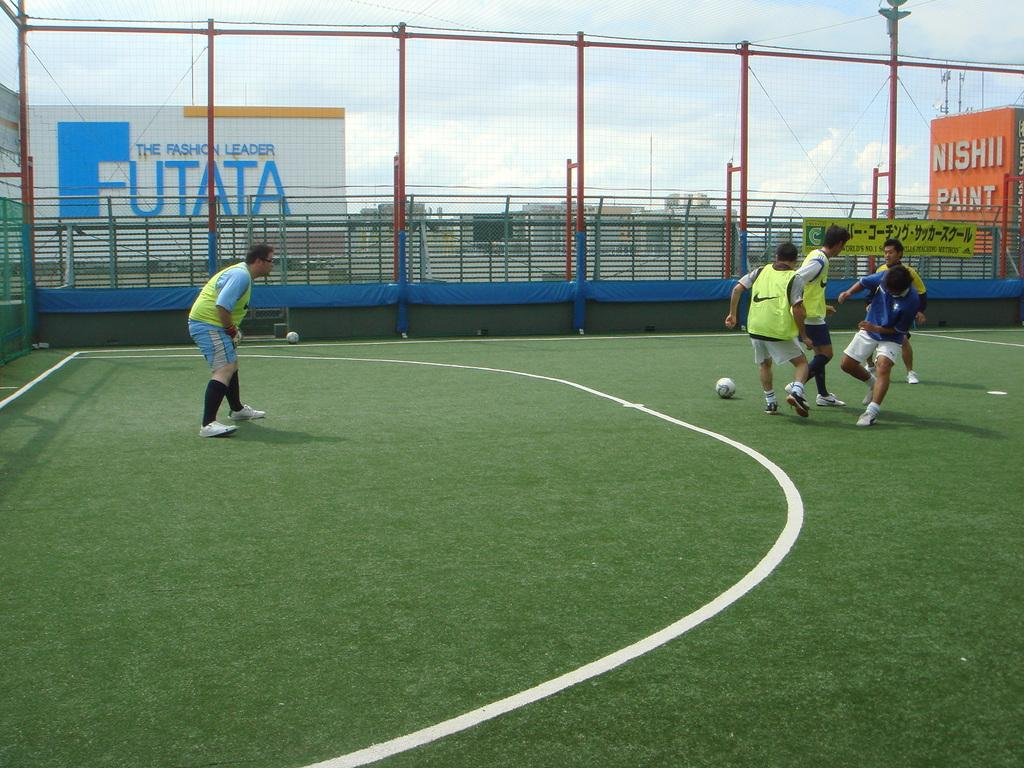<image>
Render a clear and concise summary of the photo. A group of men playing soccer on a fake turf field at the top of a building near a Nishii Paint sign and a Futata billboard. 